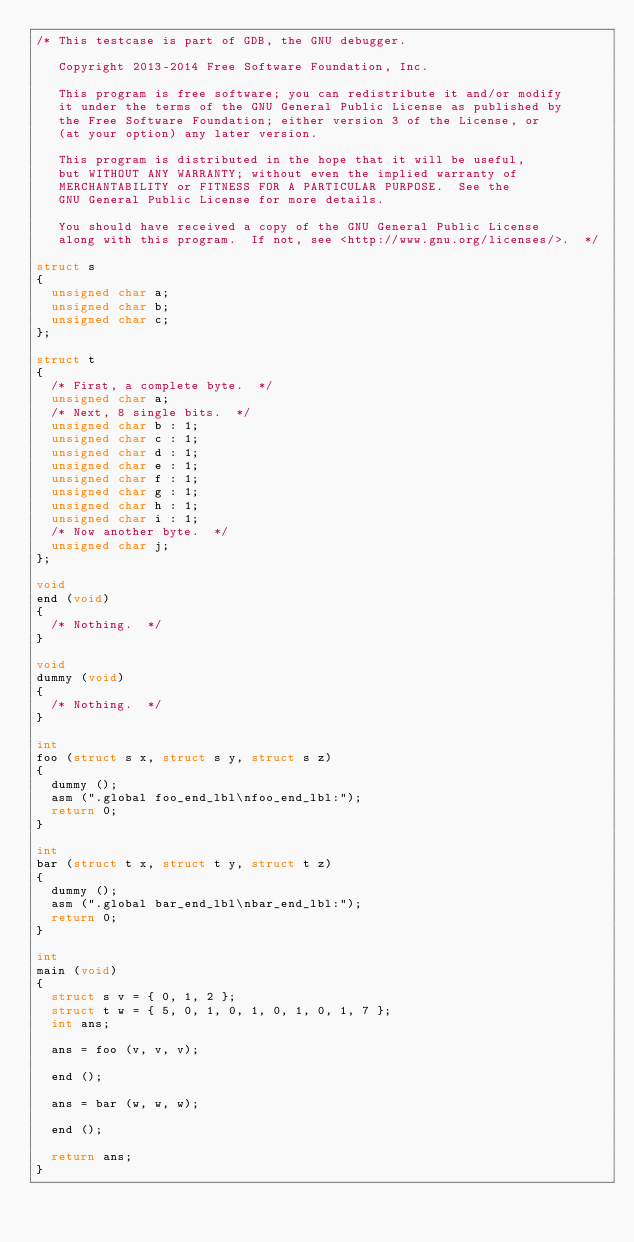<code> <loc_0><loc_0><loc_500><loc_500><_C_>/* This testcase is part of GDB, the GNU debugger.

   Copyright 2013-2014 Free Software Foundation, Inc.

   This program is free software; you can redistribute it and/or modify
   it under the terms of the GNU General Public License as published by
   the Free Software Foundation; either version 3 of the License, or
   (at your option) any later version.

   This program is distributed in the hope that it will be useful,
   but WITHOUT ANY WARRANTY; without even the implied warranty of
   MERCHANTABILITY or FITNESS FOR A PARTICULAR PURPOSE.  See the
   GNU General Public License for more details.

   You should have received a copy of the GNU General Public License
   along with this program.  If not, see <http://www.gnu.org/licenses/>.  */

struct s
{
  unsigned char a;
  unsigned char b;
  unsigned char c;
};

struct t
{
  /* First, a complete byte.  */
  unsigned char a;
  /* Next, 8 single bits.  */
  unsigned char b : 1;
  unsigned char c : 1;
  unsigned char d : 1;
  unsigned char e : 1;
  unsigned char f : 1;
  unsigned char g : 1;
  unsigned char h : 1;
  unsigned char i : 1;
  /* Now another byte.  */
  unsigned char j;
};

void
end (void)
{
  /* Nothing.  */
}

void
dummy (void)
{
  /* Nothing.  */
}

int
foo (struct s x, struct s y, struct s z)
{
  dummy ();
  asm (".global foo_end_lbl\nfoo_end_lbl:");
  return 0;
}

int
bar (struct t x, struct t y, struct t z)
{
  dummy ();
  asm (".global bar_end_lbl\nbar_end_lbl:");
  return 0;
}

int
main (void)
{
  struct s v = { 0, 1, 2 };
  struct t w = { 5, 0, 1, 0, 1, 0, 1, 0, 1, 7 };
  int ans;

  ans = foo (v, v, v);

  end ();

  ans = bar (w, w, w);

  end ();

  return ans;
}
</code> 